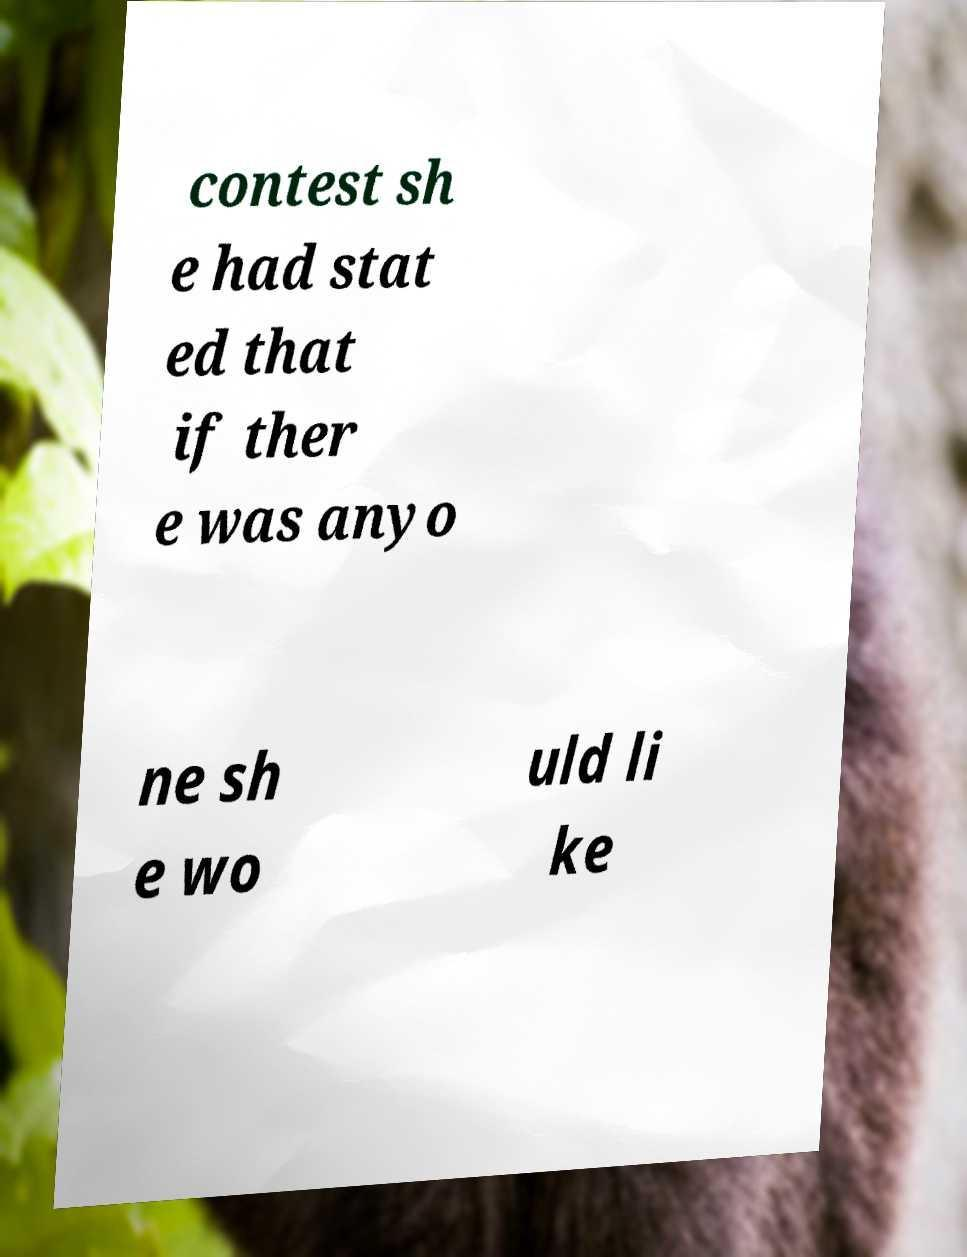Could you extract and type out the text from this image? contest sh e had stat ed that if ther e was anyo ne sh e wo uld li ke 